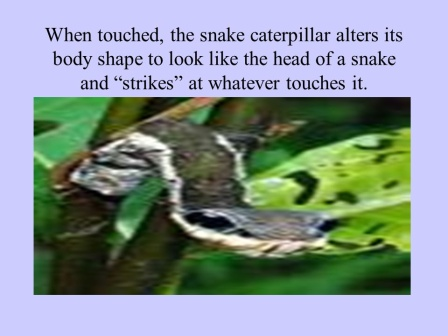Can you describe the defensive mechanisms seen in caterpillars like this one? Certainly! Many caterpillars employ a variety of defensive mechanisms to protect themselves from predators. The snake caterpillar, as depicted in the image, uses mimicry as a primary defense. By altering its body shape to resemble the head of a snake, this caterpillar can scare off potential threats. This specific mimicry involves precise coloration and posture changes, making the caterpillar a convincing snake look-alike. In addition to snake mimicry, some caterpillars use other tactics, such as displaying eye spots to appear larger to predators, releasing noxious chemicals, or employing camouflage to blend into their environment. These strategies showcase the diverse and ingenious ways caterpillars have evolved to survive. What could be other possible adaptations for survival in caterpillars and insects? In addition to mimicry like that of the snake caterpillar, caterpillars and other insects have evolved a diverse array of adaptations to survive. These adaptations include physical defenses such as spines or bristles that can irritate predators, chemical defenses like toxins or foul-tasting substances, and behavioral strategies such as freezing in place or wriggling to dislodge themselves from a threat. Some caterpillars are able to blend into their surroundings through cryptic coloration, making them almost invisible amongst leaves and twigs. Others congregate in large groups to create confusion and reduce individual predation risk. These varied strategies highlight the incredible adaptability and resourcefulness of caterpillars and insects in avoiding predation and ensuring their survival. 